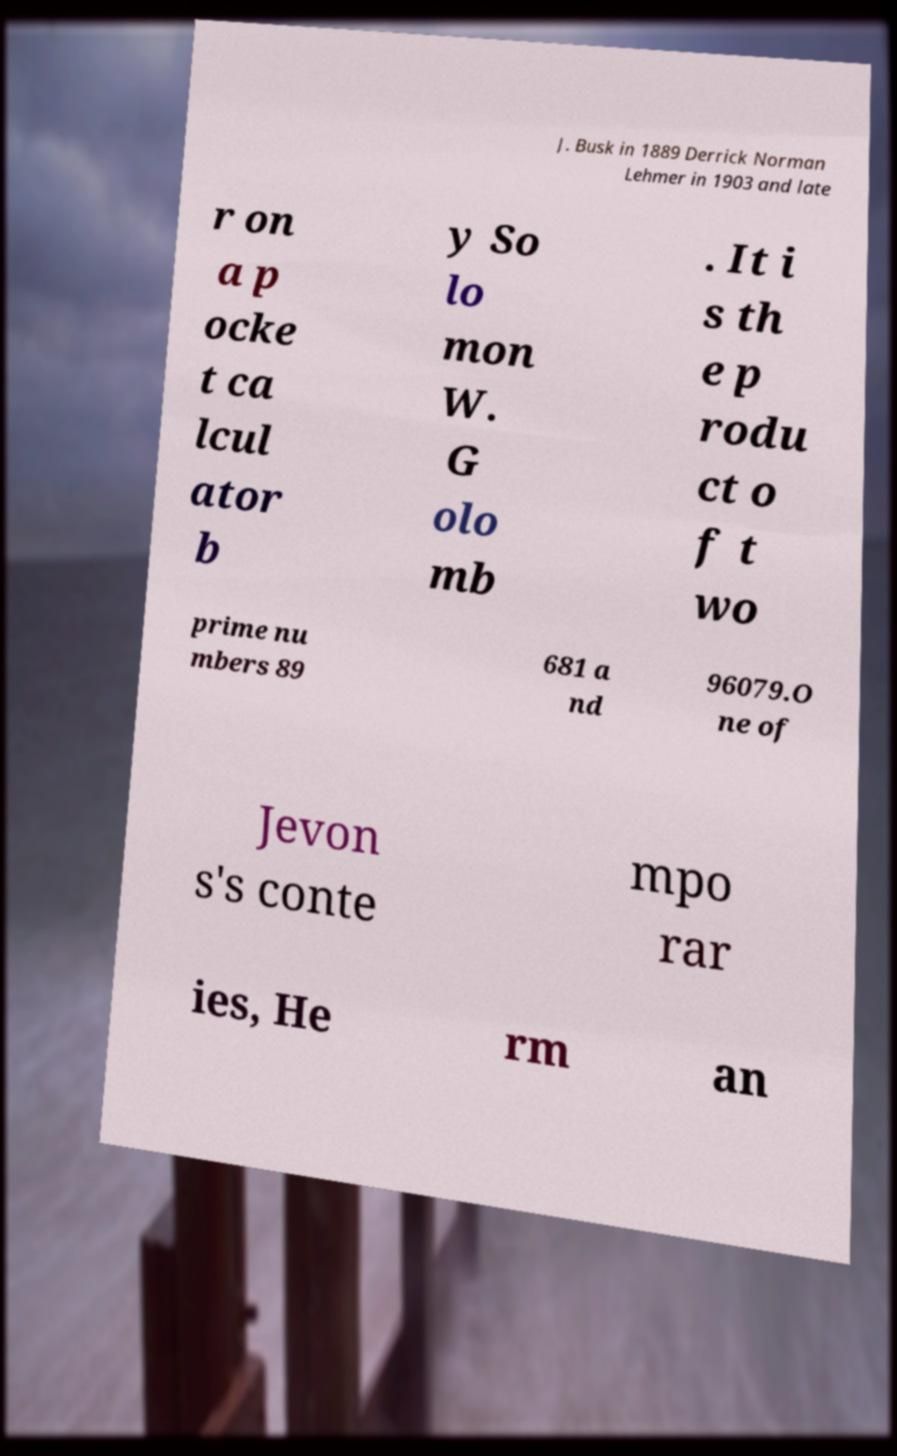For documentation purposes, I need the text within this image transcribed. Could you provide that? J. Busk in 1889 Derrick Norman Lehmer in 1903 and late r on a p ocke t ca lcul ator b y So lo mon W. G olo mb . It i s th e p rodu ct o f t wo prime nu mbers 89 681 a nd 96079.O ne of Jevon s's conte mpo rar ies, He rm an 